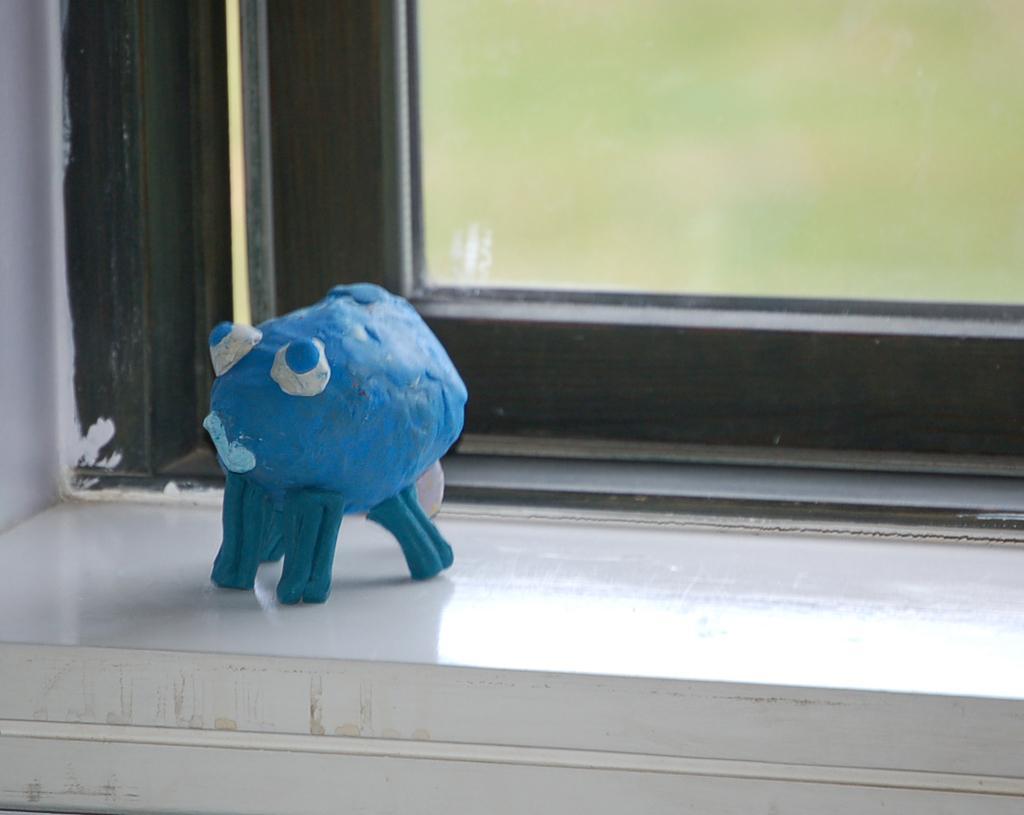In one or two sentences, can you explain what this image depicts? This image consists of a toy in blue color is kept on a wall near the window. In the background, there is a window. The toy looks like octopus. 